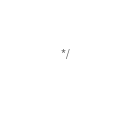<code> <loc_0><loc_0><loc_500><loc_500><_CSS_>*/</code> 